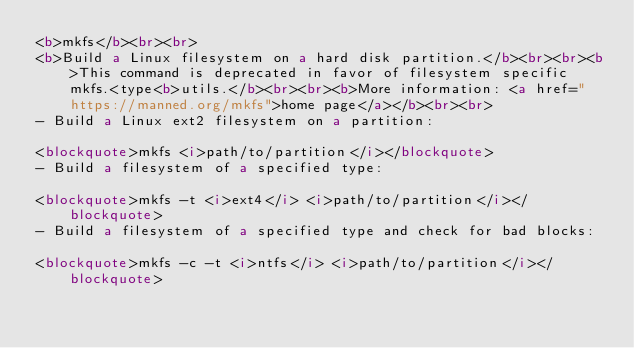<code> <loc_0><loc_0><loc_500><loc_500><_HTML_><b>mkfs</b><br><br>
<b>Build a Linux filesystem on a hard disk partition.</b><br><br><b>This command is deprecated in favor of filesystem specific mkfs.<type<b>utils.</b><br><br><b>More information: <a href="https://manned.org/mkfs">home page</a></b><br><br>
- Build a Linux ext2 filesystem on a partition:

<blockquote>mkfs <i>path/to/partition</i></blockquote>
- Build a filesystem of a specified type:

<blockquote>mkfs -t <i>ext4</i> <i>path/to/partition</i></blockquote>
- Build a filesystem of a specified type and check for bad blocks:

<blockquote>mkfs -c -t <i>ntfs</i> <i>path/to/partition</i></blockquote>
</code> 